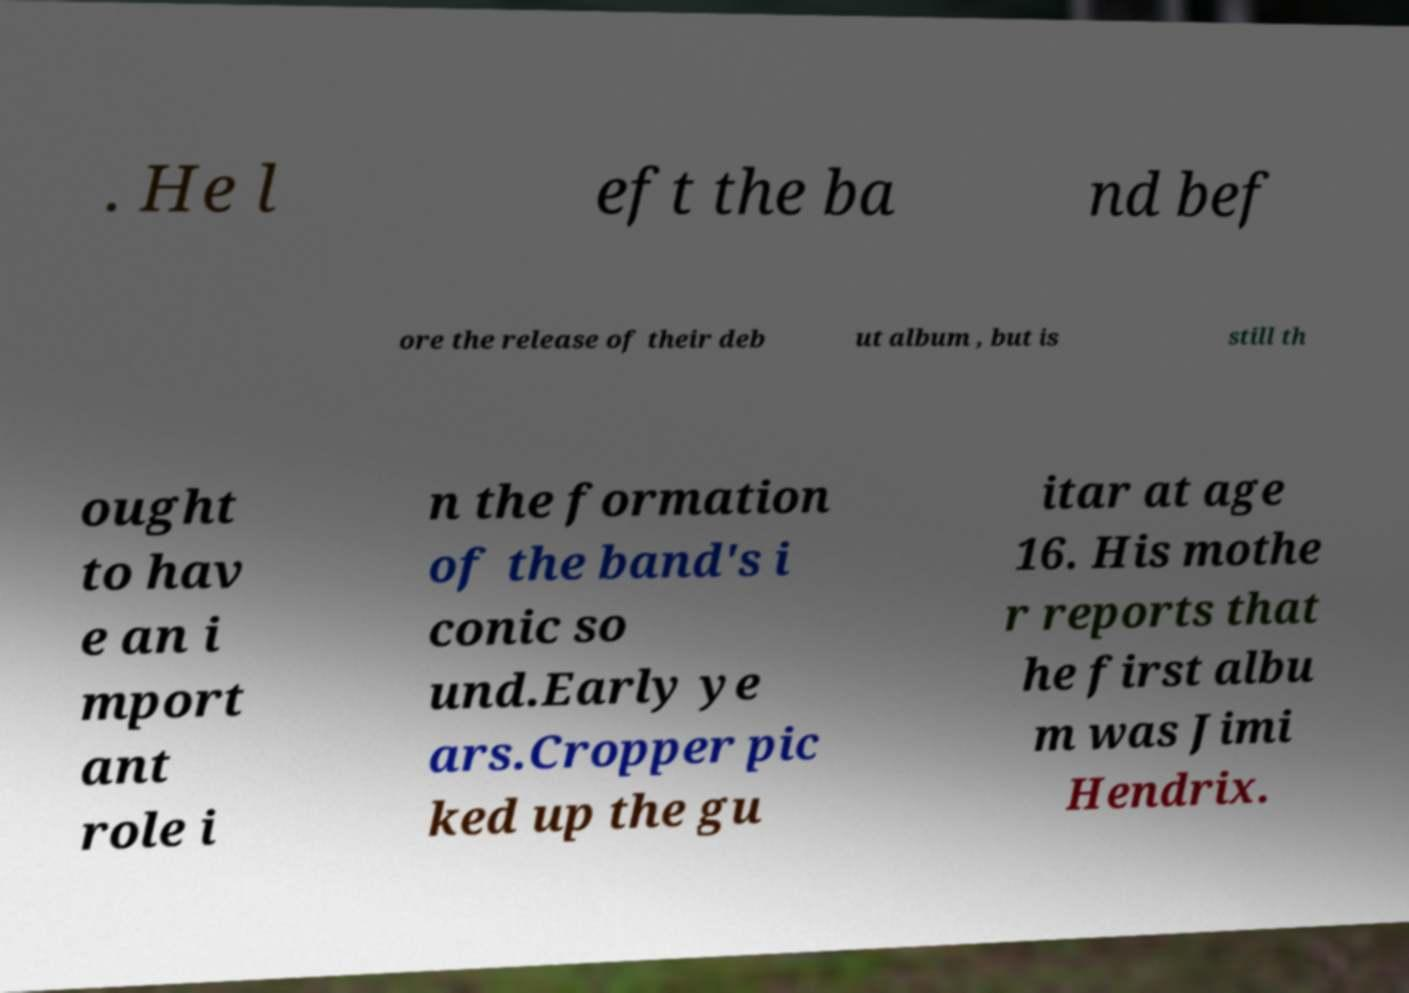Can you accurately transcribe the text from the provided image for me? . He l eft the ba nd bef ore the release of their deb ut album , but is still th ought to hav e an i mport ant role i n the formation of the band's i conic so und.Early ye ars.Cropper pic ked up the gu itar at age 16. His mothe r reports that he first albu m was Jimi Hendrix. 